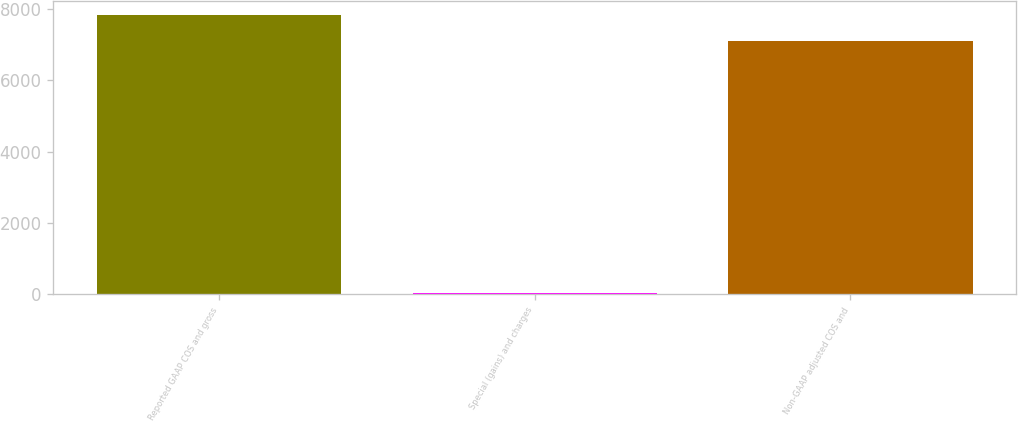<chart> <loc_0><loc_0><loc_500><loc_500><bar_chart><fcel>Reported GAAP COS and gross<fcel>Special (gains) and charges<fcel>Non-GAAP adjusted COS and<nl><fcel>7829.8<fcel>43.2<fcel>7118<nl></chart> 